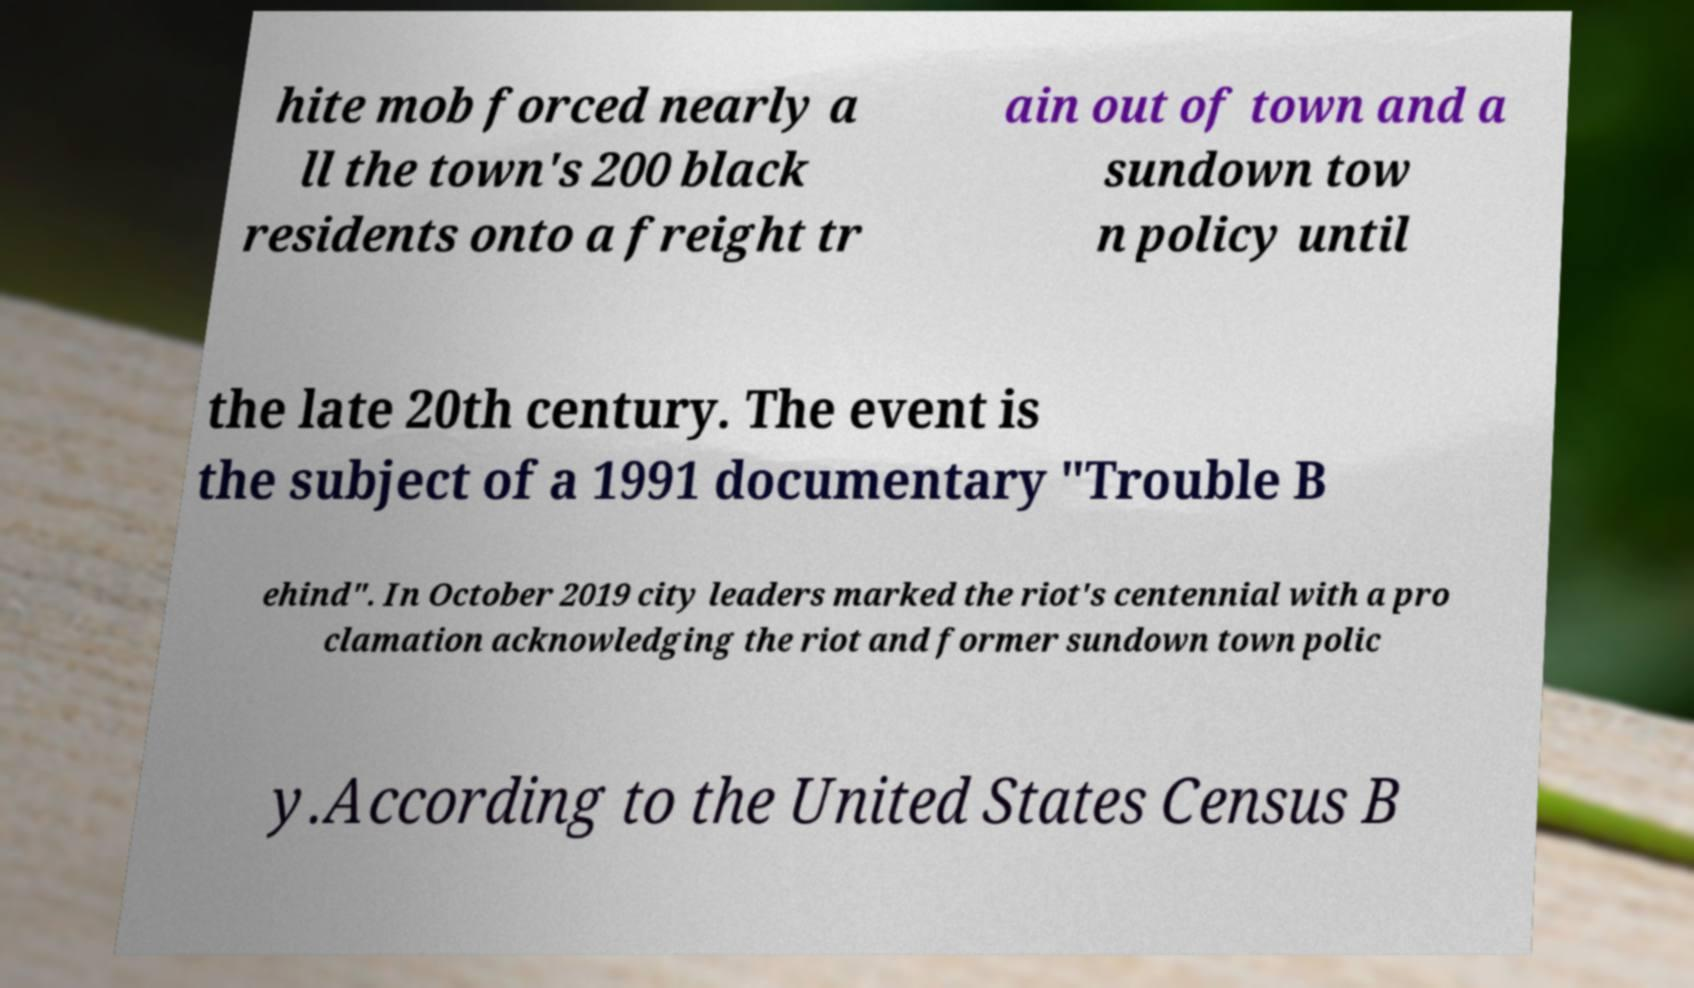Could you assist in decoding the text presented in this image and type it out clearly? hite mob forced nearly a ll the town's 200 black residents onto a freight tr ain out of town and a sundown tow n policy until the late 20th century. The event is the subject of a 1991 documentary "Trouble B ehind". In October 2019 city leaders marked the riot's centennial with a pro clamation acknowledging the riot and former sundown town polic y.According to the United States Census B 